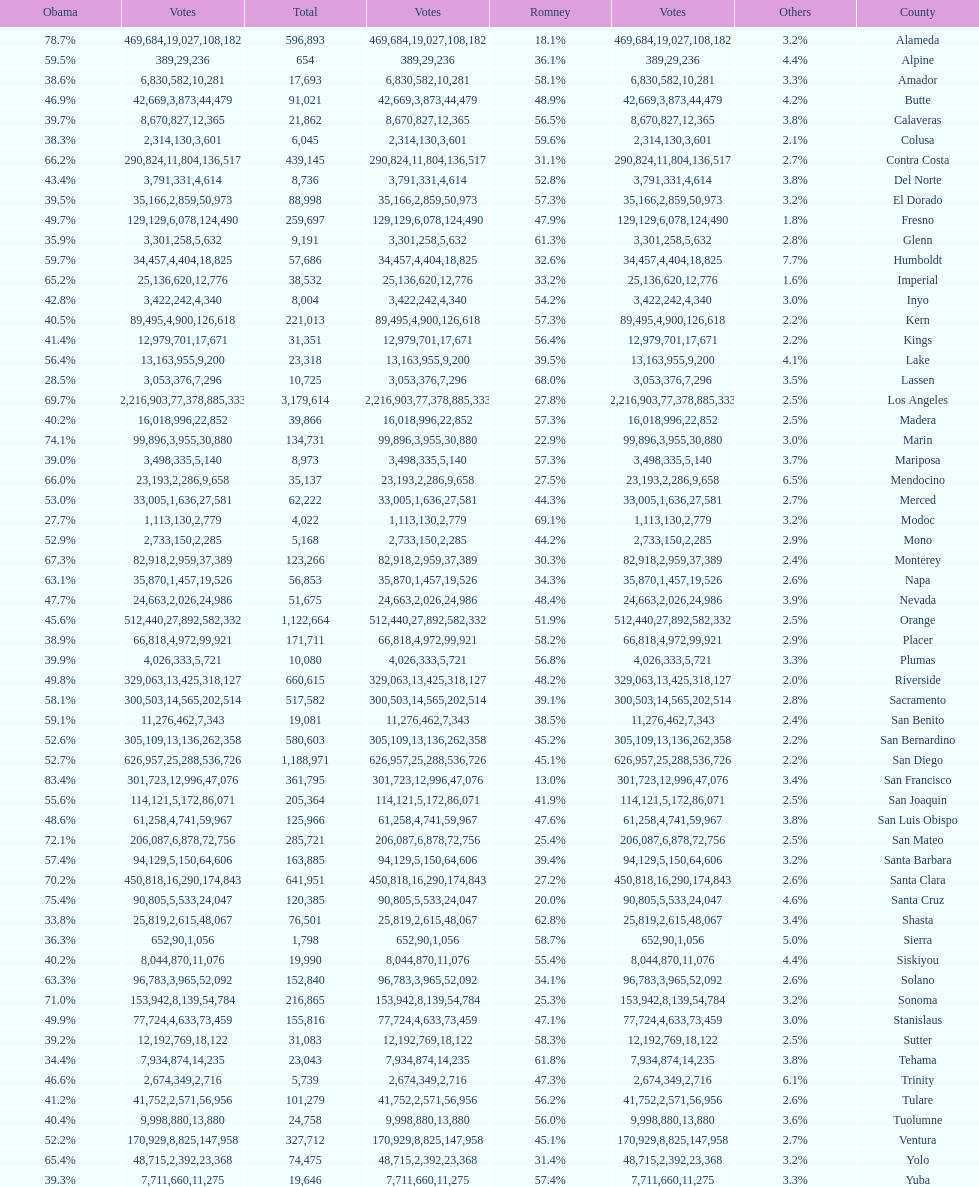Which count had the least number of votes for obama? Modoc. Parse the table in full. {'header': ['Obama', 'Votes', 'Total', 'Votes', 'Romney', 'Votes', 'Others', 'County'], 'rows': [['78.7%', '469,684', '596,893', '19,027', '18.1%', '108,182', '3.2%', 'Alameda'], ['59.5%', '389', '654', '29', '36.1%', '236', '4.4%', 'Alpine'], ['38.6%', '6,830', '17,693', '582', '58.1%', '10,281', '3.3%', 'Amador'], ['46.9%', '42,669', '91,021', '3,873', '48.9%', '44,479', '4.2%', 'Butte'], ['39.7%', '8,670', '21,862', '827', '56.5%', '12,365', '3.8%', 'Calaveras'], ['38.3%', '2,314', '6,045', '130', '59.6%', '3,601', '2.1%', 'Colusa'], ['66.2%', '290,824', '439,145', '11,804', '31.1%', '136,517', '2.7%', 'Contra Costa'], ['43.4%', '3,791', '8,736', '331', '52.8%', '4,614', '3.8%', 'Del Norte'], ['39.5%', '35,166', '88,998', '2,859', '57.3%', '50,973', '3.2%', 'El Dorado'], ['49.7%', '129,129', '259,697', '6,078', '47.9%', '124,490', '1.8%', 'Fresno'], ['35.9%', '3,301', '9,191', '258', '61.3%', '5,632', '2.8%', 'Glenn'], ['59.7%', '34,457', '57,686', '4,404', '32.6%', '18,825', '7.7%', 'Humboldt'], ['65.2%', '25,136', '38,532', '620', '33.2%', '12,776', '1.6%', 'Imperial'], ['42.8%', '3,422', '8,004', '242', '54.2%', '4,340', '3.0%', 'Inyo'], ['40.5%', '89,495', '221,013', '4,900', '57.3%', '126,618', '2.2%', 'Kern'], ['41.4%', '12,979', '31,351', '701', '56.4%', '17,671', '2.2%', 'Kings'], ['56.4%', '13,163', '23,318', '955', '39.5%', '9,200', '4.1%', 'Lake'], ['28.5%', '3,053', '10,725', '376', '68.0%', '7,296', '3.5%', 'Lassen'], ['69.7%', '2,216,903', '3,179,614', '77,378', '27.8%', '885,333', '2.5%', 'Los Angeles'], ['40.2%', '16,018', '39,866', '996', '57.3%', '22,852', '2.5%', 'Madera'], ['74.1%', '99,896', '134,731', '3,955', '22.9%', '30,880', '3.0%', 'Marin'], ['39.0%', '3,498', '8,973', '335', '57.3%', '5,140', '3.7%', 'Mariposa'], ['66.0%', '23,193', '35,137', '2,286', '27.5%', '9,658', '6.5%', 'Mendocino'], ['53.0%', '33,005', '62,222', '1,636', '44.3%', '27,581', '2.7%', 'Merced'], ['27.7%', '1,113', '4,022', '130', '69.1%', '2,779', '3.2%', 'Modoc'], ['52.9%', '2,733', '5,168', '150', '44.2%', '2,285', '2.9%', 'Mono'], ['67.3%', '82,918', '123,266', '2,959', '30.3%', '37,389', '2.4%', 'Monterey'], ['63.1%', '35,870', '56,853', '1,457', '34.3%', '19,526', '2.6%', 'Napa'], ['47.7%', '24,663', '51,675', '2,026', '48.4%', '24,986', '3.9%', 'Nevada'], ['45.6%', '512,440', '1,122,664', '27,892', '51.9%', '582,332', '2.5%', 'Orange'], ['38.9%', '66,818', '171,711', '4,972', '58.2%', '99,921', '2.9%', 'Placer'], ['39.9%', '4,026', '10,080', '333', '56.8%', '5,721', '3.3%', 'Plumas'], ['49.8%', '329,063', '660,615', '13,425', '48.2%', '318,127', '2.0%', 'Riverside'], ['58.1%', '300,503', '517,582', '14,565', '39.1%', '202,514', '2.8%', 'Sacramento'], ['59.1%', '11,276', '19,081', '462', '38.5%', '7,343', '2.4%', 'San Benito'], ['52.6%', '305,109', '580,603', '13,136', '45.2%', '262,358', '2.2%', 'San Bernardino'], ['52.7%', '626,957', '1,188,971', '25,288', '45.1%', '536,726', '2.2%', 'San Diego'], ['83.4%', '301,723', '361,795', '12,996', '13.0%', '47,076', '3.4%', 'San Francisco'], ['55.6%', '114,121', '205,364', '5,172', '41.9%', '86,071', '2.5%', 'San Joaquin'], ['48.6%', '61,258', '125,966', '4,741', '47.6%', '59,967', '3.8%', 'San Luis Obispo'], ['72.1%', '206,087', '285,721', '6,878', '25.4%', '72,756', '2.5%', 'San Mateo'], ['57.4%', '94,129', '163,885', '5,150', '39.4%', '64,606', '3.2%', 'Santa Barbara'], ['70.2%', '450,818', '641,951', '16,290', '27.2%', '174,843', '2.6%', 'Santa Clara'], ['75.4%', '90,805', '120,385', '5,533', '20.0%', '24,047', '4.6%', 'Santa Cruz'], ['33.8%', '25,819', '76,501', '2,615', '62.8%', '48,067', '3.4%', 'Shasta'], ['36.3%', '652', '1,798', '90', '58.7%', '1,056', '5.0%', 'Sierra'], ['40.2%', '8,044', '19,990', '870', '55.4%', '11,076', '4.4%', 'Siskiyou'], ['63.3%', '96,783', '152,840', '3,965', '34.1%', '52,092', '2.6%', 'Solano'], ['71.0%', '153,942', '216,865', '8,139', '25.3%', '54,784', '3.2%', 'Sonoma'], ['49.9%', '77,724', '155,816', '4,633', '47.1%', '73,459', '3.0%', 'Stanislaus'], ['39.2%', '12,192', '31,083', '769', '58.3%', '18,122', '2.5%', 'Sutter'], ['34.4%', '7,934', '23,043', '874', '61.8%', '14,235', '3.8%', 'Tehama'], ['46.6%', '2,674', '5,739', '349', '47.3%', '2,716', '6.1%', 'Trinity'], ['41.2%', '41,752', '101,279', '2,571', '56.2%', '56,956', '2.6%', 'Tulare'], ['40.4%', '9,998', '24,758', '880', '56.0%', '13,880', '3.6%', 'Tuolumne'], ['52.2%', '170,929', '327,712', '8,825', '45.1%', '147,958', '2.7%', 'Ventura'], ['65.4%', '48,715', '74,475', '2,392', '31.4%', '23,368', '3.2%', 'Yolo'], ['39.3%', '7,711', '19,646', '660', '57.4%', '11,275', '3.3%', 'Yuba']]} 